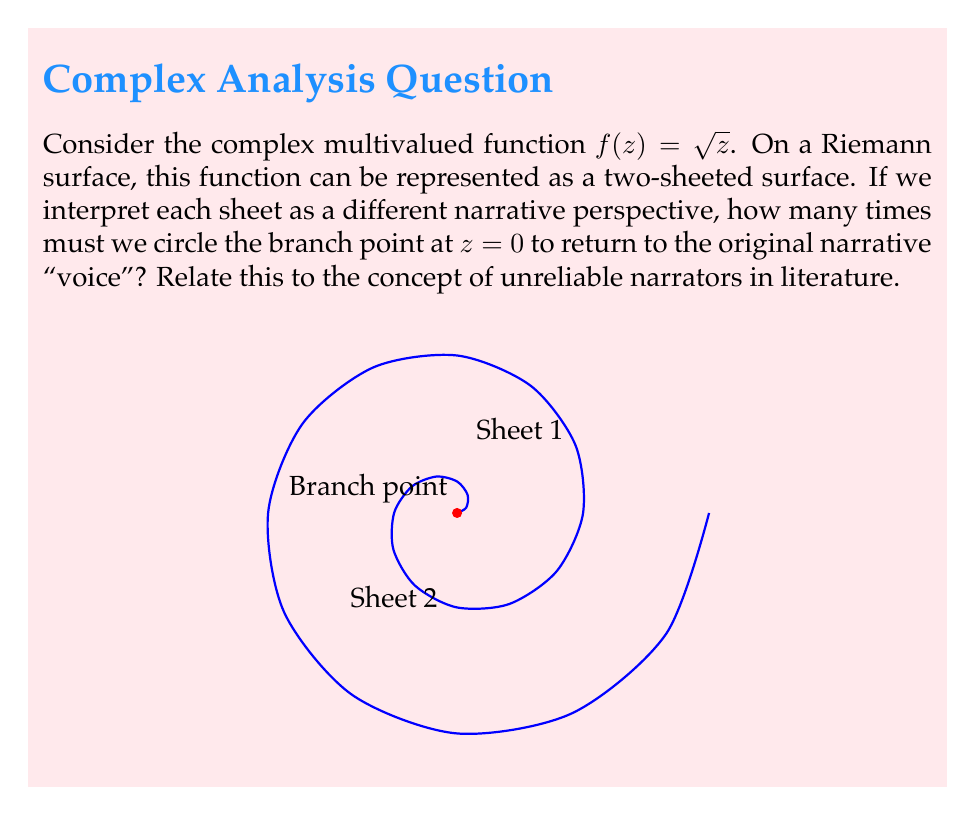Teach me how to tackle this problem. To approach this problem, let's break it down step-by-step:

1) The function $f(z) = \sqrt{z}$ is a multivalued function in the complex plane. For each non-zero complex number, there are two possible square roots.

2) A Riemann surface for this function consists of two sheets, each representing one of the two possible values of the square root.

3) The branch point at $z=0$ is where these two sheets connect. This point is analogous to a moment in a narrative where the reliability of the narrator becomes questionable.

4) As we move around the branch point in the complex plane, we switch between the two sheets of the Riemann surface. This is similar to how a reader might switch between trusting and doubting an unreliable narrator.

5) To mathematically determine how many times we need to circle the branch point to return to the original sheet:
   - Let $z = re^{i\theta}$ be a point in the complex plane.
   - Then $\sqrt{z} = \sqrt{r}e^{i\theta/2}$.
   - As $\theta$ increases by $2\pi$ (one full rotation), the argument of $\sqrt{z}$ increases by $\pi$.
   - This means we've moved to the other sheet of the Riemann surface.

6) To return to the original sheet (and thus the original "narrative voice"), we need to complete another full rotation.

7) Therefore, we must circle the branch point twice (a total rotation of $4\pi$) to return to the original sheet/narrative perspective.

In literature, this double rotation mirrors the process a reader might go through with an unreliable narrator: first doubting the narrator's reliability, then potentially coming to understand or accept their perspective again.
Answer: 2 rotations (corresponding to $4\pi$ radians) 